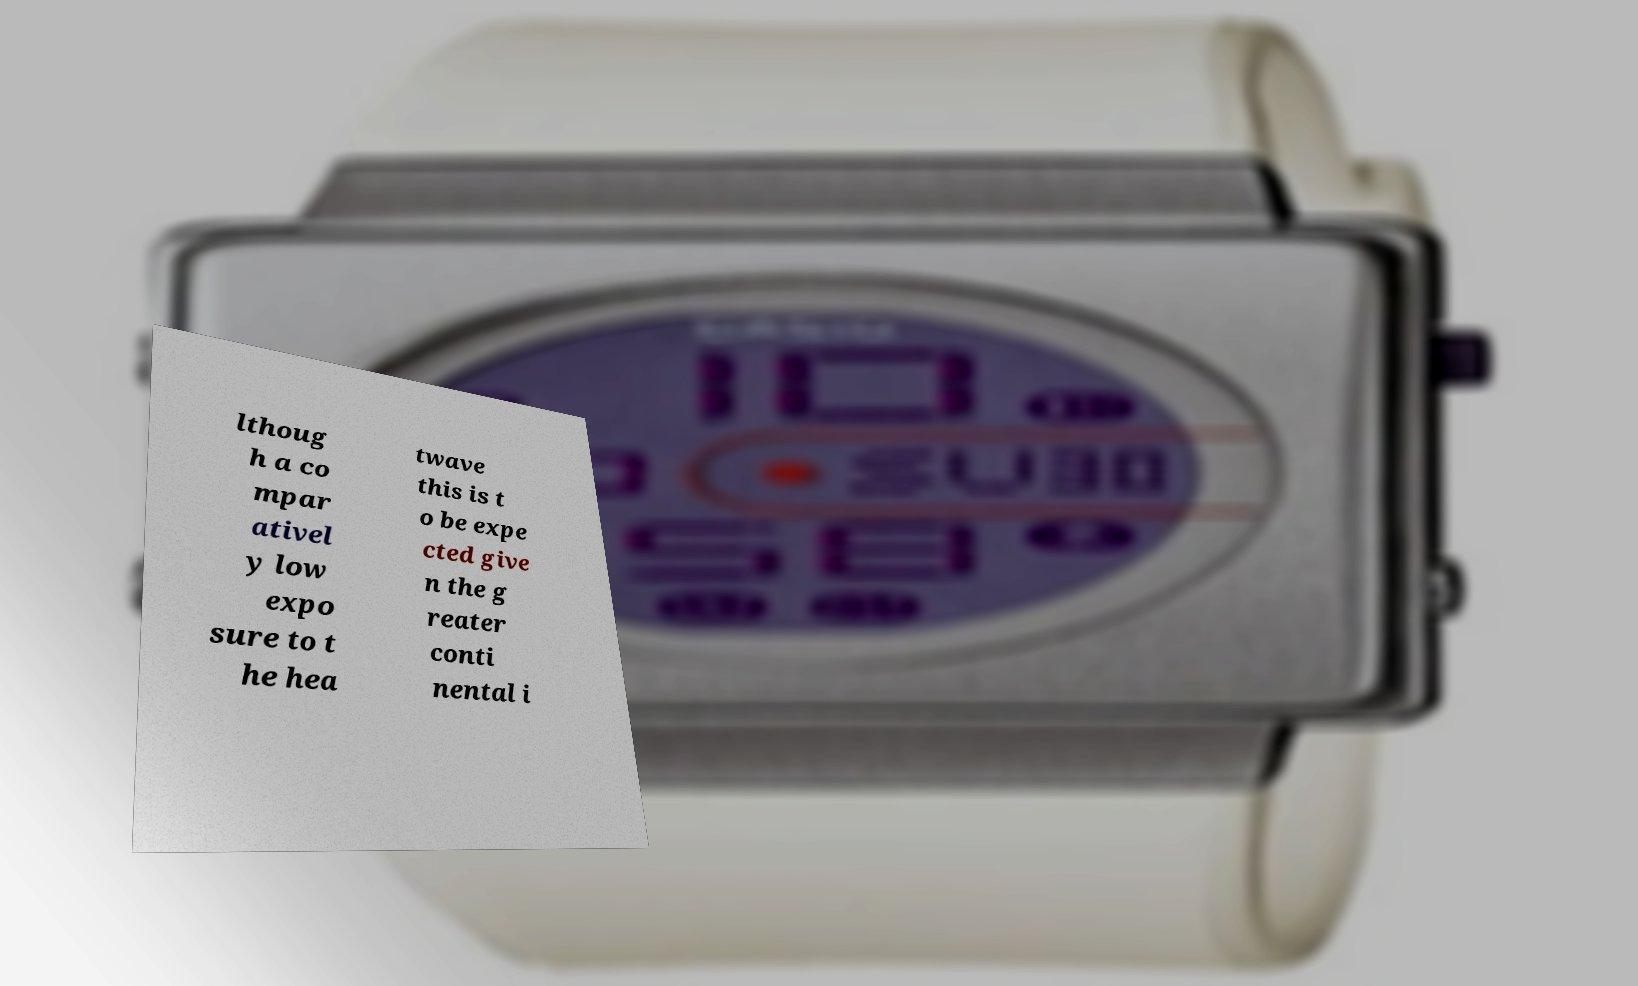I need the written content from this picture converted into text. Can you do that? lthoug h a co mpar ativel y low expo sure to t he hea twave this is t o be expe cted give n the g reater conti nental i 